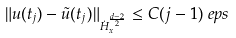Convert formula to latex. <formula><loc_0><loc_0><loc_500><loc_500>\| u ( t _ { j } ) - \tilde { u } ( t _ { j } ) \| _ { \dot { H } ^ { \frac { d - 2 } 2 } _ { x } } & \leq C ( j - 1 ) \ e p s</formula> 